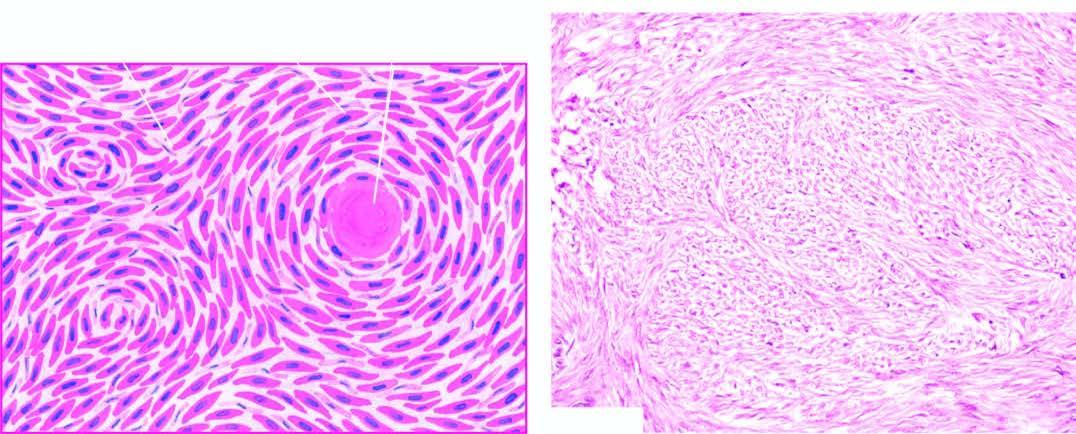does microscopy show whorls of smooth muscle cells which are spindle-shaped, having abundant cytoplasm and oval nuclei?
Answer the question using a single word or phrase. Yes 